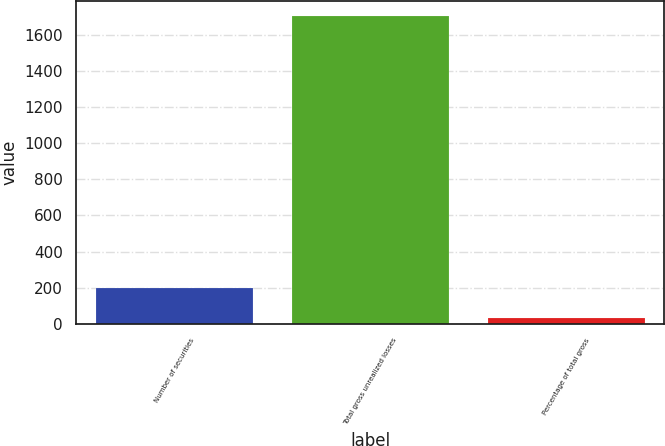<chart> <loc_0><loc_0><loc_500><loc_500><bar_chart><fcel>Number of securities<fcel>Total gross unrealized losses<fcel>Percentage of total gross<nl><fcel>198.2<fcel>1703<fcel>31<nl></chart> 